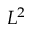Convert formula to latex. <formula><loc_0><loc_0><loc_500><loc_500>L ^ { 2 }</formula> 